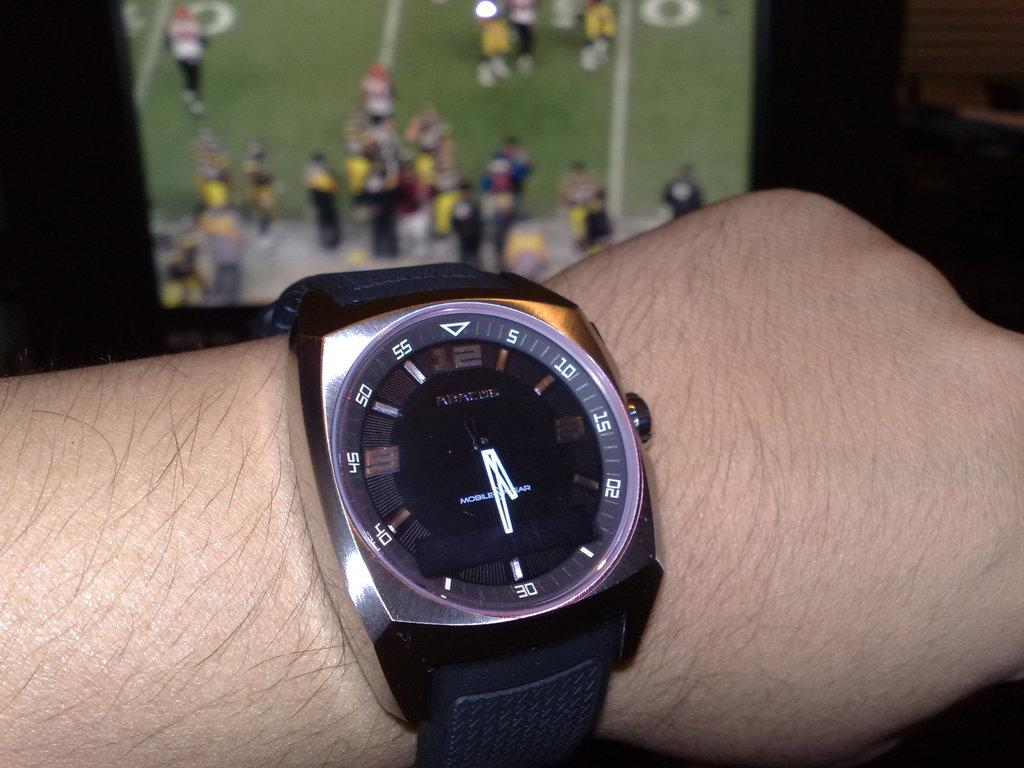Provide a one-sentence caption for the provided image. The minute hand of the watch pointed at 30 minutes. 